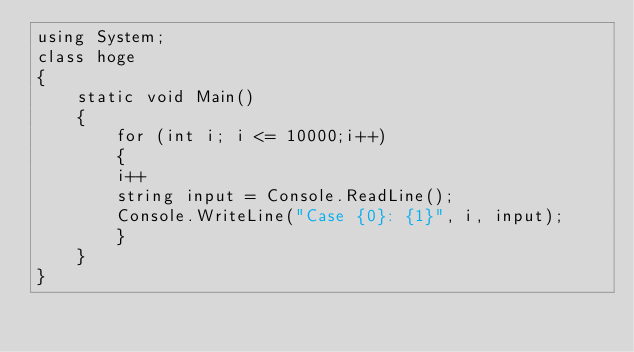Convert code to text. <code><loc_0><loc_0><loc_500><loc_500><_C#_>using System;
class hoge
{
    static void Main()
    {
        for (int i; i <= 10000;i++)
        {
        i++
        string input = Console.ReadLine();
        Console.WriteLine("Case {0}: {1}", i, input);
        }
    }
}</code> 